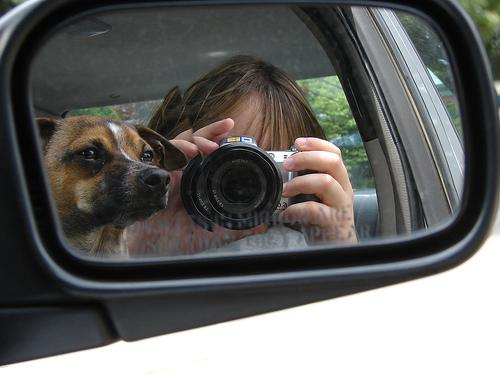Question: what animal is in the photo?
Choices:
A. An elephant.
B. A cat.
C. A dog.
D. A rabbit.
Answer with the letter. Answer: C Question: where is this picture taken?
Choices:
A. Car.
B. Truck.
C. Train.
D. Subway.
Answer with the letter. Answer: A Question: what is the person doing?
Choices:
A. Taking a picture.
B. Looking at a camera.
C. Snapping a photo.
D. Answering a call.
Answer with the letter. Answer: A Question: who is taking the picture?
Choices:
A. The man.
B. The child.
C. The girl.
D. The woman.
Answer with the letter. Answer: D Question: what is the person holding?
Choices:
A. A phone.
B. A camera.
C. A pager.
D. A tablet.
Answer with the letter. Answer: B 